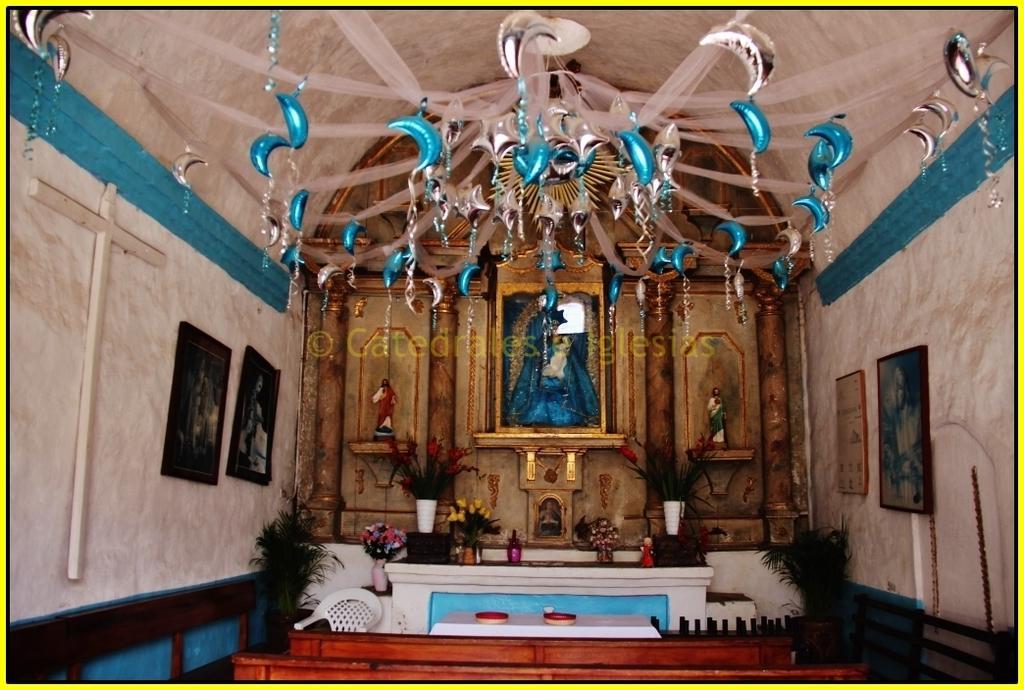How would you summarize this image in a sentence or two? This is an edited image with the borders. In the foreground we can see the wooden objects which seems to be the tables and we can see some objects are placed on the top of the table and we can see a chair, flower vases, potted plants and a table like object on the top of which we can see the flower vases and some objects are placed. At the top there is a roof and we can see the depictions of some objects are hanging on the roof. On both the sides we can see the picture frames hanging on the walls. In the background we can see the objects which seems to be the sculptures and we can see some other objects in the background. 